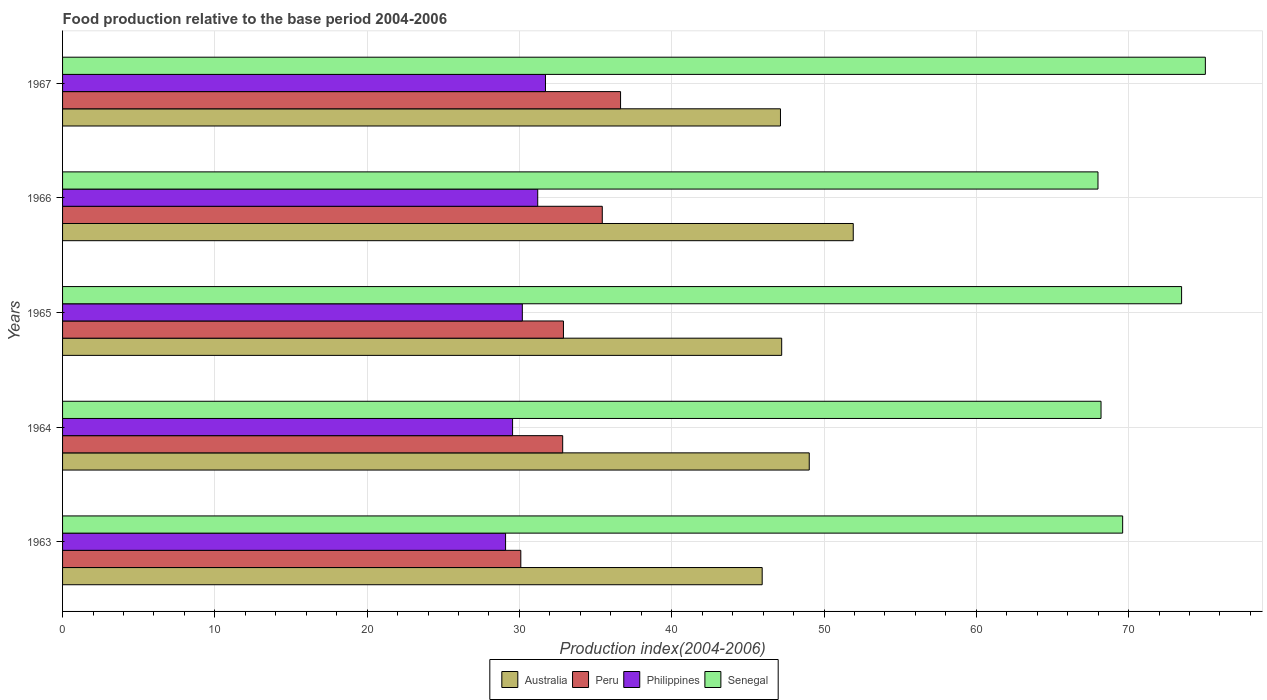How many groups of bars are there?
Your response must be concise. 5. Are the number of bars per tick equal to the number of legend labels?
Provide a short and direct response. Yes. Are the number of bars on each tick of the Y-axis equal?
Provide a succinct answer. Yes. How many bars are there on the 1st tick from the bottom?
Your answer should be compact. 4. What is the label of the 2nd group of bars from the top?
Your answer should be compact. 1966. In how many cases, is the number of bars for a given year not equal to the number of legend labels?
Offer a terse response. 0. What is the food production index in Australia in 1966?
Offer a terse response. 51.92. Across all years, what is the maximum food production index in Australia?
Your answer should be compact. 51.92. Across all years, what is the minimum food production index in Australia?
Your response must be concise. 45.94. In which year was the food production index in Australia maximum?
Your answer should be compact. 1966. What is the total food production index in Australia in the graph?
Offer a very short reply. 241.25. What is the difference between the food production index in Peru in 1963 and that in 1967?
Provide a short and direct response. -6.55. What is the difference between the food production index in Australia in 1966 and the food production index in Senegal in 1967?
Your response must be concise. -23.12. What is the average food production index in Australia per year?
Your response must be concise. 48.25. In the year 1965, what is the difference between the food production index in Philippines and food production index in Senegal?
Your answer should be compact. -43.29. In how many years, is the food production index in Australia greater than 24 ?
Offer a terse response. 5. What is the ratio of the food production index in Peru in 1964 to that in 1966?
Ensure brevity in your answer.  0.93. What is the difference between the highest and the second highest food production index in Philippines?
Keep it short and to the point. 0.51. What is the difference between the highest and the lowest food production index in Australia?
Your answer should be compact. 5.98. Is the sum of the food production index in Peru in 1964 and 1967 greater than the maximum food production index in Senegal across all years?
Provide a short and direct response. No. Is it the case that in every year, the sum of the food production index in Peru and food production index in Philippines is greater than the sum of food production index in Senegal and food production index in Australia?
Offer a terse response. No. What does the 4th bar from the top in 1965 represents?
Offer a terse response. Australia. How many years are there in the graph?
Offer a terse response. 5. Does the graph contain grids?
Keep it short and to the point. Yes. How are the legend labels stacked?
Ensure brevity in your answer.  Horizontal. What is the title of the graph?
Provide a short and direct response. Food production relative to the base period 2004-2006. What is the label or title of the X-axis?
Provide a succinct answer. Production index(2004-2006). What is the label or title of the Y-axis?
Offer a very short reply. Years. What is the Production index(2004-2006) in Australia in 1963?
Ensure brevity in your answer.  45.94. What is the Production index(2004-2006) in Peru in 1963?
Ensure brevity in your answer.  30.09. What is the Production index(2004-2006) in Philippines in 1963?
Ensure brevity in your answer.  29.09. What is the Production index(2004-2006) in Senegal in 1963?
Offer a very short reply. 69.61. What is the Production index(2004-2006) in Australia in 1964?
Your answer should be compact. 49.03. What is the Production index(2004-2006) in Peru in 1964?
Your answer should be very brief. 32.84. What is the Production index(2004-2006) in Philippines in 1964?
Your answer should be compact. 29.55. What is the Production index(2004-2006) of Senegal in 1964?
Ensure brevity in your answer.  68.19. What is the Production index(2004-2006) in Australia in 1965?
Offer a terse response. 47.22. What is the Production index(2004-2006) of Peru in 1965?
Provide a short and direct response. 32.89. What is the Production index(2004-2006) in Philippines in 1965?
Keep it short and to the point. 30.19. What is the Production index(2004-2006) of Senegal in 1965?
Ensure brevity in your answer.  73.48. What is the Production index(2004-2006) in Australia in 1966?
Provide a succinct answer. 51.92. What is the Production index(2004-2006) of Peru in 1966?
Your answer should be very brief. 35.44. What is the Production index(2004-2006) of Philippines in 1966?
Keep it short and to the point. 31.2. What is the Production index(2004-2006) of Senegal in 1966?
Offer a very short reply. 67.99. What is the Production index(2004-2006) in Australia in 1967?
Offer a very short reply. 47.14. What is the Production index(2004-2006) of Peru in 1967?
Offer a very short reply. 36.64. What is the Production index(2004-2006) of Philippines in 1967?
Your answer should be compact. 31.71. What is the Production index(2004-2006) of Senegal in 1967?
Offer a terse response. 75.04. Across all years, what is the maximum Production index(2004-2006) of Australia?
Your answer should be compact. 51.92. Across all years, what is the maximum Production index(2004-2006) in Peru?
Offer a terse response. 36.64. Across all years, what is the maximum Production index(2004-2006) in Philippines?
Offer a very short reply. 31.71. Across all years, what is the maximum Production index(2004-2006) of Senegal?
Provide a succinct answer. 75.04. Across all years, what is the minimum Production index(2004-2006) in Australia?
Give a very brief answer. 45.94. Across all years, what is the minimum Production index(2004-2006) of Peru?
Give a very brief answer. 30.09. Across all years, what is the minimum Production index(2004-2006) of Philippines?
Ensure brevity in your answer.  29.09. Across all years, what is the minimum Production index(2004-2006) in Senegal?
Give a very brief answer. 67.99. What is the total Production index(2004-2006) of Australia in the graph?
Offer a very short reply. 241.25. What is the total Production index(2004-2006) of Peru in the graph?
Ensure brevity in your answer.  167.9. What is the total Production index(2004-2006) in Philippines in the graph?
Provide a short and direct response. 151.74. What is the total Production index(2004-2006) of Senegal in the graph?
Keep it short and to the point. 354.31. What is the difference between the Production index(2004-2006) of Australia in 1963 and that in 1964?
Provide a succinct answer. -3.09. What is the difference between the Production index(2004-2006) in Peru in 1963 and that in 1964?
Offer a terse response. -2.75. What is the difference between the Production index(2004-2006) in Philippines in 1963 and that in 1964?
Provide a succinct answer. -0.46. What is the difference between the Production index(2004-2006) of Senegal in 1963 and that in 1964?
Keep it short and to the point. 1.42. What is the difference between the Production index(2004-2006) of Australia in 1963 and that in 1965?
Provide a succinct answer. -1.28. What is the difference between the Production index(2004-2006) of Peru in 1963 and that in 1965?
Provide a short and direct response. -2.8. What is the difference between the Production index(2004-2006) in Philippines in 1963 and that in 1965?
Offer a very short reply. -1.1. What is the difference between the Production index(2004-2006) in Senegal in 1963 and that in 1965?
Keep it short and to the point. -3.87. What is the difference between the Production index(2004-2006) of Australia in 1963 and that in 1966?
Give a very brief answer. -5.98. What is the difference between the Production index(2004-2006) of Peru in 1963 and that in 1966?
Offer a terse response. -5.35. What is the difference between the Production index(2004-2006) of Philippines in 1963 and that in 1966?
Provide a short and direct response. -2.11. What is the difference between the Production index(2004-2006) in Senegal in 1963 and that in 1966?
Offer a very short reply. 1.62. What is the difference between the Production index(2004-2006) of Australia in 1963 and that in 1967?
Ensure brevity in your answer.  -1.2. What is the difference between the Production index(2004-2006) of Peru in 1963 and that in 1967?
Make the answer very short. -6.55. What is the difference between the Production index(2004-2006) of Philippines in 1963 and that in 1967?
Provide a succinct answer. -2.62. What is the difference between the Production index(2004-2006) of Senegal in 1963 and that in 1967?
Offer a terse response. -5.43. What is the difference between the Production index(2004-2006) in Australia in 1964 and that in 1965?
Keep it short and to the point. 1.81. What is the difference between the Production index(2004-2006) of Peru in 1964 and that in 1965?
Ensure brevity in your answer.  -0.05. What is the difference between the Production index(2004-2006) of Philippines in 1964 and that in 1965?
Offer a terse response. -0.64. What is the difference between the Production index(2004-2006) in Senegal in 1964 and that in 1965?
Your answer should be compact. -5.29. What is the difference between the Production index(2004-2006) of Australia in 1964 and that in 1966?
Your response must be concise. -2.89. What is the difference between the Production index(2004-2006) of Philippines in 1964 and that in 1966?
Give a very brief answer. -1.65. What is the difference between the Production index(2004-2006) in Australia in 1964 and that in 1967?
Offer a very short reply. 1.89. What is the difference between the Production index(2004-2006) in Philippines in 1964 and that in 1967?
Make the answer very short. -2.16. What is the difference between the Production index(2004-2006) of Senegal in 1964 and that in 1967?
Keep it short and to the point. -6.85. What is the difference between the Production index(2004-2006) of Australia in 1965 and that in 1966?
Keep it short and to the point. -4.7. What is the difference between the Production index(2004-2006) in Peru in 1965 and that in 1966?
Give a very brief answer. -2.55. What is the difference between the Production index(2004-2006) in Philippines in 1965 and that in 1966?
Your response must be concise. -1.01. What is the difference between the Production index(2004-2006) of Senegal in 1965 and that in 1966?
Make the answer very short. 5.49. What is the difference between the Production index(2004-2006) of Australia in 1965 and that in 1967?
Your answer should be very brief. 0.08. What is the difference between the Production index(2004-2006) in Peru in 1965 and that in 1967?
Offer a very short reply. -3.75. What is the difference between the Production index(2004-2006) of Philippines in 1965 and that in 1967?
Provide a short and direct response. -1.52. What is the difference between the Production index(2004-2006) of Senegal in 1965 and that in 1967?
Provide a succinct answer. -1.56. What is the difference between the Production index(2004-2006) of Australia in 1966 and that in 1967?
Your answer should be compact. 4.78. What is the difference between the Production index(2004-2006) of Philippines in 1966 and that in 1967?
Your answer should be compact. -0.51. What is the difference between the Production index(2004-2006) of Senegal in 1966 and that in 1967?
Your response must be concise. -7.05. What is the difference between the Production index(2004-2006) in Australia in 1963 and the Production index(2004-2006) in Philippines in 1964?
Your answer should be compact. 16.39. What is the difference between the Production index(2004-2006) of Australia in 1963 and the Production index(2004-2006) of Senegal in 1964?
Your answer should be very brief. -22.25. What is the difference between the Production index(2004-2006) in Peru in 1963 and the Production index(2004-2006) in Philippines in 1964?
Your answer should be compact. 0.54. What is the difference between the Production index(2004-2006) in Peru in 1963 and the Production index(2004-2006) in Senegal in 1964?
Your answer should be very brief. -38.1. What is the difference between the Production index(2004-2006) of Philippines in 1963 and the Production index(2004-2006) of Senegal in 1964?
Offer a terse response. -39.1. What is the difference between the Production index(2004-2006) in Australia in 1963 and the Production index(2004-2006) in Peru in 1965?
Offer a terse response. 13.05. What is the difference between the Production index(2004-2006) of Australia in 1963 and the Production index(2004-2006) of Philippines in 1965?
Offer a very short reply. 15.75. What is the difference between the Production index(2004-2006) in Australia in 1963 and the Production index(2004-2006) in Senegal in 1965?
Provide a succinct answer. -27.54. What is the difference between the Production index(2004-2006) in Peru in 1963 and the Production index(2004-2006) in Philippines in 1965?
Make the answer very short. -0.1. What is the difference between the Production index(2004-2006) in Peru in 1963 and the Production index(2004-2006) in Senegal in 1965?
Give a very brief answer. -43.39. What is the difference between the Production index(2004-2006) in Philippines in 1963 and the Production index(2004-2006) in Senegal in 1965?
Your answer should be very brief. -44.39. What is the difference between the Production index(2004-2006) of Australia in 1963 and the Production index(2004-2006) of Peru in 1966?
Provide a short and direct response. 10.5. What is the difference between the Production index(2004-2006) of Australia in 1963 and the Production index(2004-2006) of Philippines in 1966?
Keep it short and to the point. 14.74. What is the difference between the Production index(2004-2006) in Australia in 1963 and the Production index(2004-2006) in Senegal in 1966?
Keep it short and to the point. -22.05. What is the difference between the Production index(2004-2006) of Peru in 1963 and the Production index(2004-2006) of Philippines in 1966?
Offer a very short reply. -1.11. What is the difference between the Production index(2004-2006) of Peru in 1963 and the Production index(2004-2006) of Senegal in 1966?
Make the answer very short. -37.9. What is the difference between the Production index(2004-2006) in Philippines in 1963 and the Production index(2004-2006) in Senegal in 1966?
Keep it short and to the point. -38.9. What is the difference between the Production index(2004-2006) in Australia in 1963 and the Production index(2004-2006) in Philippines in 1967?
Make the answer very short. 14.23. What is the difference between the Production index(2004-2006) in Australia in 1963 and the Production index(2004-2006) in Senegal in 1967?
Ensure brevity in your answer.  -29.1. What is the difference between the Production index(2004-2006) in Peru in 1963 and the Production index(2004-2006) in Philippines in 1967?
Your answer should be very brief. -1.62. What is the difference between the Production index(2004-2006) in Peru in 1963 and the Production index(2004-2006) in Senegal in 1967?
Offer a terse response. -44.95. What is the difference between the Production index(2004-2006) of Philippines in 1963 and the Production index(2004-2006) of Senegal in 1967?
Your answer should be compact. -45.95. What is the difference between the Production index(2004-2006) of Australia in 1964 and the Production index(2004-2006) of Peru in 1965?
Offer a very short reply. 16.14. What is the difference between the Production index(2004-2006) of Australia in 1964 and the Production index(2004-2006) of Philippines in 1965?
Ensure brevity in your answer.  18.84. What is the difference between the Production index(2004-2006) of Australia in 1964 and the Production index(2004-2006) of Senegal in 1965?
Make the answer very short. -24.45. What is the difference between the Production index(2004-2006) in Peru in 1964 and the Production index(2004-2006) in Philippines in 1965?
Your answer should be compact. 2.65. What is the difference between the Production index(2004-2006) of Peru in 1964 and the Production index(2004-2006) of Senegal in 1965?
Provide a short and direct response. -40.64. What is the difference between the Production index(2004-2006) of Philippines in 1964 and the Production index(2004-2006) of Senegal in 1965?
Provide a succinct answer. -43.93. What is the difference between the Production index(2004-2006) of Australia in 1964 and the Production index(2004-2006) of Peru in 1966?
Offer a terse response. 13.59. What is the difference between the Production index(2004-2006) of Australia in 1964 and the Production index(2004-2006) of Philippines in 1966?
Keep it short and to the point. 17.83. What is the difference between the Production index(2004-2006) of Australia in 1964 and the Production index(2004-2006) of Senegal in 1966?
Give a very brief answer. -18.96. What is the difference between the Production index(2004-2006) of Peru in 1964 and the Production index(2004-2006) of Philippines in 1966?
Your answer should be compact. 1.64. What is the difference between the Production index(2004-2006) in Peru in 1964 and the Production index(2004-2006) in Senegal in 1966?
Your response must be concise. -35.15. What is the difference between the Production index(2004-2006) of Philippines in 1964 and the Production index(2004-2006) of Senegal in 1966?
Offer a terse response. -38.44. What is the difference between the Production index(2004-2006) in Australia in 1964 and the Production index(2004-2006) in Peru in 1967?
Your answer should be very brief. 12.39. What is the difference between the Production index(2004-2006) in Australia in 1964 and the Production index(2004-2006) in Philippines in 1967?
Your answer should be compact. 17.32. What is the difference between the Production index(2004-2006) in Australia in 1964 and the Production index(2004-2006) in Senegal in 1967?
Ensure brevity in your answer.  -26.01. What is the difference between the Production index(2004-2006) in Peru in 1964 and the Production index(2004-2006) in Philippines in 1967?
Ensure brevity in your answer.  1.13. What is the difference between the Production index(2004-2006) in Peru in 1964 and the Production index(2004-2006) in Senegal in 1967?
Make the answer very short. -42.2. What is the difference between the Production index(2004-2006) in Philippines in 1964 and the Production index(2004-2006) in Senegal in 1967?
Provide a short and direct response. -45.49. What is the difference between the Production index(2004-2006) in Australia in 1965 and the Production index(2004-2006) in Peru in 1966?
Provide a succinct answer. 11.78. What is the difference between the Production index(2004-2006) in Australia in 1965 and the Production index(2004-2006) in Philippines in 1966?
Ensure brevity in your answer.  16.02. What is the difference between the Production index(2004-2006) of Australia in 1965 and the Production index(2004-2006) of Senegal in 1966?
Make the answer very short. -20.77. What is the difference between the Production index(2004-2006) in Peru in 1965 and the Production index(2004-2006) in Philippines in 1966?
Provide a short and direct response. 1.69. What is the difference between the Production index(2004-2006) of Peru in 1965 and the Production index(2004-2006) of Senegal in 1966?
Make the answer very short. -35.1. What is the difference between the Production index(2004-2006) of Philippines in 1965 and the Production index(2004-2006) of Senegal in 1966?
Keep it short and to the point. -37.8. What is the difference between the Production index(2004-2006) of Australia in 1965 and the Production index(2004-2006) of Peru in 1967?
Ensure brevity in your answer.  10.58. What is the difference between the Production index(2004-2006) of Australia in 1965 and the Production index(2004-2006) of Philippines in 1967?
Ensure brevity in your answer.  15.51. What is the difference between the Production index(2004-2006) of Australia in 1965 and the Production index(2004-2006) of Senegal in 1967?
Your response must be concise. -27.82. What is the difference between the Production index(2004-2006) of Peru in 1965 and the Production index(2004-2006) of Philippines in 1967?
Offer a very short reply. 1.18. What is the difference between the Production index(2004-2006) in Peru in 1965 and the Production index(2004-2006) in Senegal in 1967?
Your answer should be very brief. -42.15. What is the difference between the Production index(2004-2006) in Philippines in 1965 and the Production index(2004-2006) in Senegal in 1967?
Offer a terse response. -44.85. What is the difference between the Production index(2004-2006) of Australia in 1966 and the Production index(2004-2006) of Peru in 1967?
Ensure brevity in your answer.  15.28. What is the difference between the Production index(2004-2006) of Australia in 1966 and the Production index(2004-2006) of Philippines in 1967?
Ensure brevity in your answer.  20.21. What is the difference between the Production index(2004-2006) of Australia in 1966 and the Production index(2004-2006) of Senegal in 1967?
Provide a succinct answer. -23.12. What is the difference between the Production index(2004-2006) in Peru in 1966 and the Production index(2004-2006) in Philippines in 1967?
Your answer should be very brief. 3.73. What is the difference between the Production index(2004-2006) of Peru in 1966 and the Production index(2004-2006) of Senegal in 1967?
Provide a short and direct response. -39.6. What is the difference between the Production index(2004-2006) of Philippines in 1966 and the Production index(2004-2006) of Senegal in 1967?
Give a very brief answer. -43.84. What is the average Production index(2004-2006) in Australia per year?
Make the answer very short. 48.25. What is the average Production index(2004-2006) in Peru per year?
Offer a terse response. 33.58. What is the average Production index(2004-2006) in Philippines per year?
Ensure brevity in your answer.  30.35. What is the average Production index(2004-2006) in Senegal per year?
Provide a succinct answer. 70.86. In the year 1963, what is the difference between the Production index(2004-2006) of Australia and Production index(2004-2006) of Peru?
Make the answer very short. 15.85. In the year 1963, what is the difference between the Production index(2004-2006) of Australia and Production index(2004-2006) of Philippines?
Ensure brevity in your answer.  16.85. In the year 1963, what is the difference between the Production index(2004-2006) in Australia and Production index(2004-2006) in Senegal?
Ensure brevity in your answer.  -23.67. In the year 1963, what is the difference between the Production index(2004-2006) in Peru and Production index(2004-2006) in Senegal?
Your answer should be very brief. -39.52. In the year 1963, what is the difference between the Production index(2004-2006) in Philippines and Production index(2004-2006) in Senegal?
Your answer should be very brief. -40.52. In the year 1964, what is the difference between the Production index(2004-2006) in Australia and Production index(2004-2006) in Peru?
Your answer should be very brief. 16.19. In the year 1964, what is the difference between the Production index(2004-2006) in Australia and Production index(2004-2006) in Philippines?
Make the answer very short. 19.48. In the year 1964, what is the difference between the Production index(2004-2006) in Australia and Production index(2004-2006) in Senegal?
Your answer should be very brief. -19.16. In the year 1964, what is the difference between the Production index(2004-2006) in Peru and Production index(2004-2006) in Philippines?
Your answer should be compact. 3.29. In the year 1964, what is the difference between the Production index(2004-2006) of Peru and Production index(2004-2006) of Senegal?
Provide a short and direct response. -35.35. In the year 1964, what is the difference between the Production index(2004-2006) of Philippines and Production index(2004-2006) of Senegal?
Offer a terse response. -38.64. In the year 1965, what is the difference between the Production index(2004-2006) of Australia and Production index(2004-2006) of Peru?
Your answer should be compact. 14.33. In the year 1965, what is the difference between the Production index(2004-2006) of Australia and Production index(2004-2006) of Philippines?
Your response must be concise. 17.03. In the year 1965, what is the difference between the Production index(2004-2006) of Australia and Production index(2004-2006) of Senegal?
Ensure brevity in your answer.  -26.26. In the year 1965, what is the difference between the Production index(2004-2006) in Peru and Production index(2004-2006) in Senegal?
Provide a short and direct response. -40.59. In the year 1965, what is the difference between the Production index(2004-2006) of Philippines and Production index(2004-2006) of Senegal?
Ensure brevity in your answer.  -43.29. In the year 1966, what is the difference between the Production index(2004-2006) in Australia and Production index(2004-2006) in Peru?
Give a very brief answer. 16.48. In the year 1966, what is the difference between the Production index(2004-2006) in Australia and Production index(2004-2006) in Philippines?
Provide a succinct answer. 20.72. In the year 1966, what is the difference between the Production index(2004-2006) in Australia and Production index(2004-2006) in Senegal?
Offer a very short reply. -16.07. In the year 1966, what is the difference between the Production index(2004-2006) in Peru and Production index(2004-2006) in Philippines?
Offer a very short reply. 4.24. In the year 1966, what is the difference between the Production index(2004-2006) of Peru and Production index(2004-2006) of Senegal?
Offer a terse response. -32.55. In the year 1966, what is the difference between the Production index(2004-2006) in Philippines and Production index(2004-2006) in Senegal?
Keep it short and to the point. -36.79. In the year 1967, what is the difference between the Production index(2004-2006) in Australia and Production index(2004-2006) in Peru?
Offer a very short reply. 10.5. In the year 1967, what is the difference between the Production index(2004-2006) of Australia and Production index(2004-2006) of Philippines?
Provide a succinct answer. 15.43. In the year 1967, what is the difference between the Production index(2004-2006) in Australia and Production index(2004-2006) in Senegal?
Your answer should be very brief. -27.9. In the year 1967, what is the difference between the Production index(2004-2006) of Peru and Production index(2004-2006) of Philippines?
Provide a succinct answer. 4.93. In the year 1967, what is the difference between the Production index(2004-2006) in Peru and Production index(2004-2006) in Senegal?
Your answer should be compact. -38.4. In the year 1967, what is the difference between the Production index(2004-2006) of Philippines and Production index(2004-2006) of Senegal?
Make the answer very short. -43.33. What is the ratio of the Production index(2004-2006) in Australia in 1963 to that in 1964?
Your answer should be compact. 0.94. What is the ratio of the Production index(2004-2006) of Peru in 1963 to that in 1964?
Your answer should be compact. 0.92. What is the ratio of the Production index(2004-2006) of Philippines in 1963 to that in 1964?
Your answer should be compact. 0.98. What is the ratio of the Production index(2004-2006) of Senegal in 1963 to that in 1964?
Ensure brevity in your answer.  1.02. What is the ratio of the Production index(2004-2006) in Australia in 1963 to that in 1965?
Keep it short and to the point. 0.97. What is the ratio of the Production index(2004-2006) of Peru in 1963 to that in 1965?
Give a very brief answer. 0.91. What is the ratio of the Production index(2004-2006) of Philippines in 1963 to that in 1965?
Provide a succinct answer. 0.96. What is the ratio of the Production index(2004-2006) of Senegal in 1963 to that in 1965?
Give a very brief answer. 0.95. What is the ratio of the Production index(2004-2006) of Australia in 1963 to that in 1966?
Your response must be concise. 0.88. What is the ratio of the Production index(2004-2006) in Peru in 1963 to that in 1966?
Offer a very short reply. 0.85. What is the ratio of the Production index(2004-2006) in Philippines in 1963 to that in 1966?
Provide a short and direct response. 0.93. What is the ratio of the Production index(2004-2006) in Senegal in 1963 to that in 1966?
Offer a terse response. 1.02. What is the ratio of the Production index(2004-2006) in Australia in 1963 to that in 1967?
Your answer should be compact. 0.97. What is the ratio of the Production index(2004-2006) of Peru in 1963 to that in 1967?
Give a very brief answer. 0.82. What is the ratio of the Production index(2004-2006) of Philippines in 1963 to that in 1967?
Provide a succinct answer. 0.92. What is the ratio of the Production index(2004-2006) in Senegal in 1963 to that in 1967?
Your answer should be very brief. 0.93. What is the ratio of the Production index(2004-2006) in Australia in 1964 to that in 1965?
Make the answer very short. 1.04. What is the ratio of the Production index(2004-2006) in Peru in 1964 to that in 1965?
Keep it short and to the point. 1. What is the ratio of the Production index(2004-2006) of Philippines in 1964 to that in 1965?
Ensure brevity in your answer.  0.98. What is the ratio of the Production index(2004-2006) in Senegal in 1964 to that in 1965?
Your answer should be compact. 0.93. What is the ratio of the Production index(2004-2006) of Australia in 1964 to that in 1966?
Make the answer very short. 0.94. What is the ratio of the Production index(2004-2006) of Peru in 1964 to that in 1966?
Offer a terse response. 0.93. What is the ratio of the Production index(2004-2006) of Philippines in 1964 to that in 1966?
Keep it short and to the point. 0.95. What is the ratio of the Production index(2004-2006) of Senegal in 1964 to that in 1966?
Offer a terse response. 1. What is the ratio of the Production index(2004-2006) in Australia in 1964 to that in 1967?
Your answer should be very brief. 1.04. What is the ratio of the Production index(2004-2006) in Peru in 1964 to that in 1967?
Your answer should be very brief. 0.9. What is the ratio of the Production index(2004-2006) in Philippines in 1964 to that in 1967?
Your answer should be compact. 0.93. What is the ratio of the Production index(2004-2006) of Senegal in 1964 to that in 1967?
Your response must be concise. 0.91. What is the ratio of the Production index(2004-2006) in Australia in 1965 to that in 1966?
Your answer should be very brief. 0.91. What is the ratio of the Production index(2004-2006) of Peru in 1965 to that in 1966?
Provide a short and direct response. 0.93. What is the ratio of the Production index(2004-2006) of Philippines in 1965 to that in 1966?
Make the answer very short. 0.97. What is the ratio of the Production index(2004-2006) in Senegal in 1965 to that in 1966?
Make the answer very short. 1.08. What is the ratio of the Production index(2004-2006) in Australia in 1965 to that in 1967?
Offer a terse response. 1. What is the ratio of the Production index(2004-2006) in Peru in 1965 to that in 1967?
Offer a terse response. 0.9. What is the ratio of the Production index(2004-2006) in Philippines in 1965 to that in 1967?
Keep it short and to the point. 0.95. What is the ratio of the Production index(2004-2006) of Senegal in 1965 to that in 1967?
Provide a succinct answer. 0.98. What is the ratio of the Production index(2004-2006) of Australia in 1966 to that in 1967?
Offer a terse response. 1.1. What is the ratio of the Production index(2004-2006) in Peru in 1966 to that in 1967?
Ensure brevity in your answer.  0.97. What is the ratio of the Production index(2004-2006) in Philippines in 1966 to that in 1967?
Ensure brevity in your answer.  0.98. What is the ratio of the Production index(2004-2006) in Senegal in 1966 to that in 1967?
Make the answer very short. 0.91. What is the difference between the highest and the second highest Production index(2004-2006) in Australia?
Provide a succinct answer. 2.89. What is the difference between the highest and the second highest Production index(2004-2006) of Peru?
Offer a terse response. 1.2. What is the difference between the highest and the second highest Production index(2004-2006) in Philippines?
Your answer should be compact. 0.51. What is the difference between the highest and the second highest Production index(2004-2006) in Senegal?
Your answer should be compact. 1.56. What is the difference between the highest and the lowest Production index(2004-2006) of Australia?
Provide a succinct answer. 5.98. What is the difference between the highest and the lowest Production index(2004-2006) of Peru?
Your answer should be very brief. 6.55. What is the difference between the highest and the lowest Production index(2004-2006) in Philippines?
Give a very brief answer. 2.62. What is the difference between the highest and the lowest Production index(2004-2006) in Senegal?
Give a very brief answer. 7.05. 